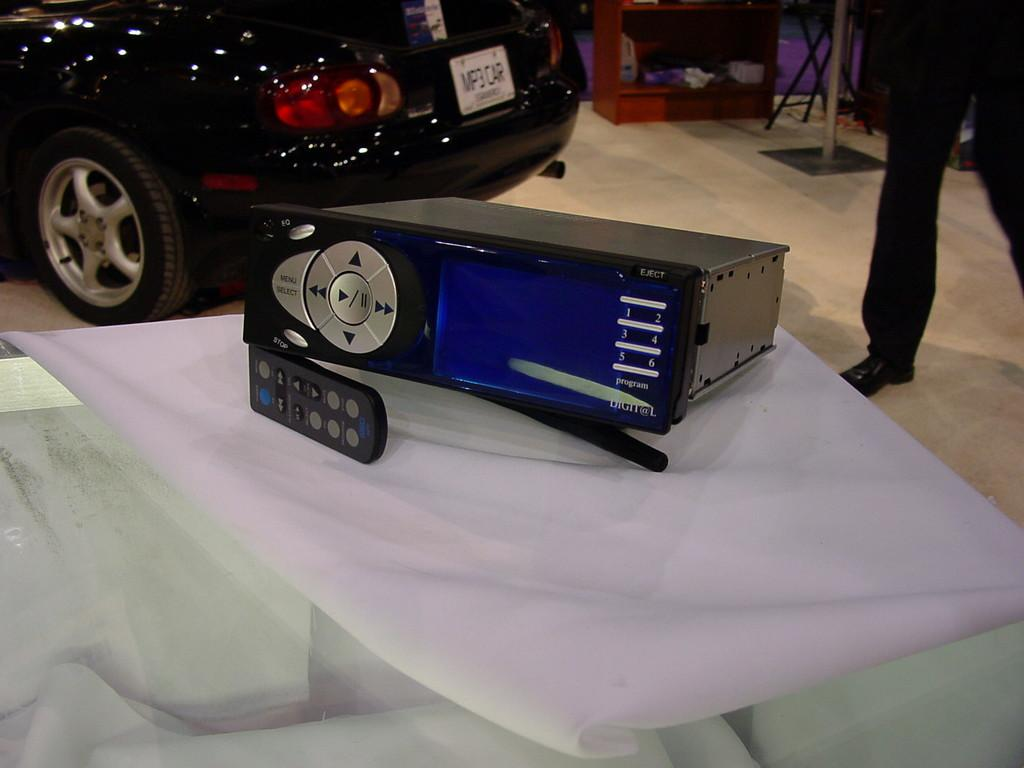What electronic device is on the table in the image? There is a CD player on the table in the image. Can you describe the person in the background? There is a person standing in the background, and they are wearing black pants. Is there any black color clothing visible in the image? Yes, there is a black color pant visible in the image. What type of bomb is visible in the image? There is no bomb present in the image. How does the person in the background attract attention in the image? The image does not provide information about how the person is attracting attention. 